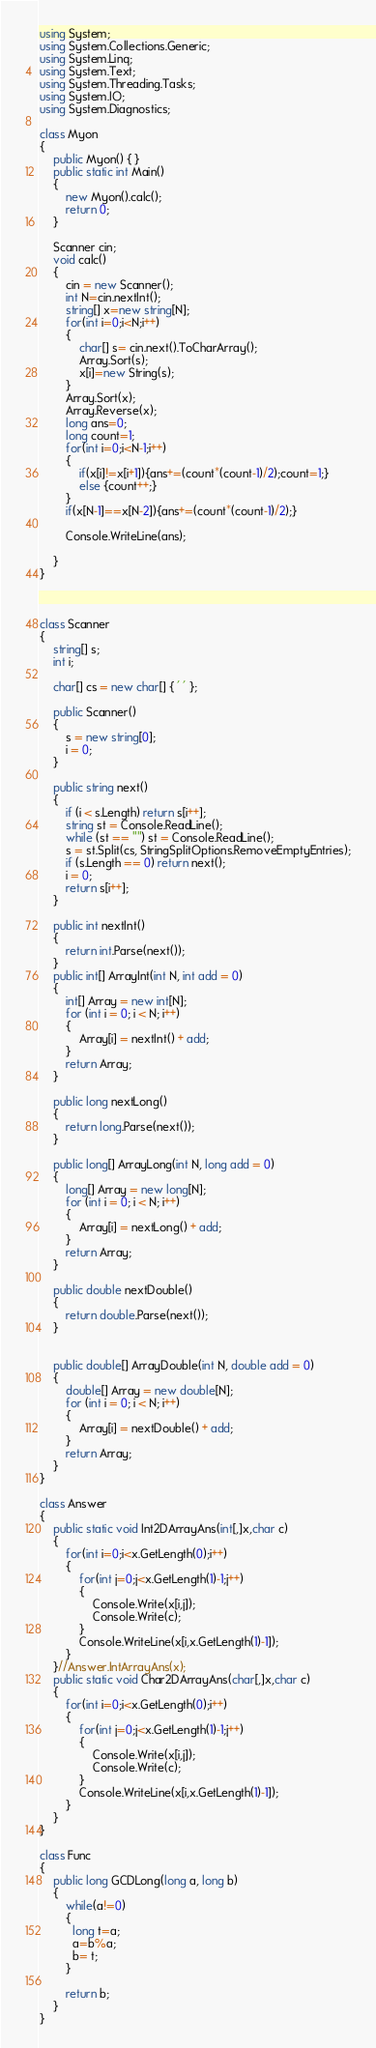Convert code to text. <code><loc_0><loc_0><loc_500><loc_500><_C#_>using System;
using System.Collections.Generic;
using System.Linq;
using System.Text;
using System.Threading.Tasks;
using System.IO;
using System.Diagnostics;

class Myon
{
    public Myon() { }
    public static int Main()
    {
        new Myon().calc();
        return 0;
    }

    Scanner cin;
    void calc()
    {
        cin = new Scanner();
        int N=cin.nextInt();
        string[] x=new string[N];
        for(int i=0;i<N;i++)
        {
            char[] s= cin.next().ToCharArray();
            Array.Sort(s);
            x[i]=new String(s);
        }
        Array.Sort(x);
        Array.Reverse(x);
        long ans=0;
        long count=1;
        for(int i=0;i<N-1;i++)
        {
            if(x[i]!=x[i+1]){ans+=(count*(count-1)/2);count=1;}
            else {count++;}
        }
        if(x[N-1]==x[N-2]){ans+=(count*(count-1)/2);}
        
        Console.WriteLine(ans);
        
    }
}



class Scanner
{
    string[] s;
    int i;

    char[] cs = new char[] { ' ' };

    public Scanner()
    {
        s = new string[0];
        i = 0;
    }

    public string next()
    {
        if (i < s.Length) return s[i++];
        string st = Console.ReadLine();
        while (st == "") st = Console.ReadLine();
        s = st.Split(cs, StringSplitOptions.RemoveEmptyEntries);
        if (s.Length == 0) return next();
        i = 0;
        return s[i++];
    }

    public int nextInt()
    {
        return int.Parse(next());
    }
    public int[] ArrayInt(int N, int add = 0)
    {
        int[] Array = new int[N];
        for (int i = 0; i < N; i++)
        {
            Array[i] = nextInt() + add;
        }
        return Array;
    }

    public long nextLong()
    {
        return long.Parse(next());
    }

    public long[] ArrayLong(int N, long add = 0)
    {
        long[] Array = new long[N];
        for (int i = 0; i < N; i++)
        {
            Array[i] = nextLong() + add;
        }
        return Array;
    }

    public double nextDouble()
    {
        return double.Parse(next());
    }


    public double[] ArrayDouble(int N, double add = 0)
    {
        double[] Array = new double[N];
        for (int i = 0; i < N; i++)
        {
            Array[i] = nextDouble() + add;
        }
        return Array;
    }
}

class Answer
{
    public static void Int2DArrayAns(int[,]x,char c)
    {
        for(int i=0;i<x.GetLength(0);i++)
        {
            for(int j=0;j<x.GetLength(1)-1;j++)
            {
                Console.Write(x[i,j]);
                Console.Write(c);
            }
            Console.WriteLine(x[i,x.GetLength(1)-1]);
        }
    }//Answer.IntArrayAns(x);
    public static void Char2DArrayAns(char[,]x,char c)
    {
        for(int i=0;i<x.GetLength(0);i++)
        {
            for(int j=0;j<x.GetLength(1)-1;j++)
            {
                Console.Write(x[i,j]);
                Console.Write(c);
            }
            Console.WriteLine(x[i,x.GetLength(1)-1]);
        }
    }
}

class Func
{
    public long GCDLong(long a, long b)
    {
        while(a!=0)
        {
          long t=a;
          a=b%a;
          b= t;
        }
      
        return b;        
    }
}
</code> 